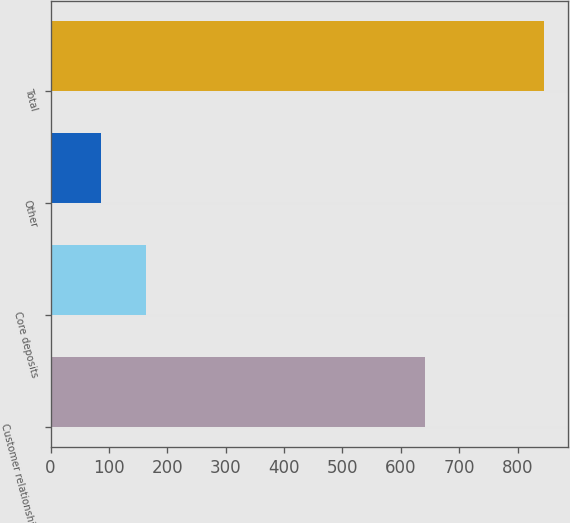Convert chart to OTSL. <chart><loc_0><loc_0><loc_500><loc_500><bar_chart><fcel>Customer relationships<fcel>Core deposits<fcel>Other<fcel>Total<nl><fcel>641<fcel>162.8<fcel>87<fcel>845<nl></chart> 